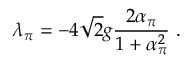<formula> <loc_0><loc_0><loc_500><loc_500>\lambda _ { \pi } = - 4 \sqrt { 2 } g \frac { 2 \alpha _ { \pi } } { 1 + \alpha _ { \pi } ^ { 2 } } \ .</formula> 